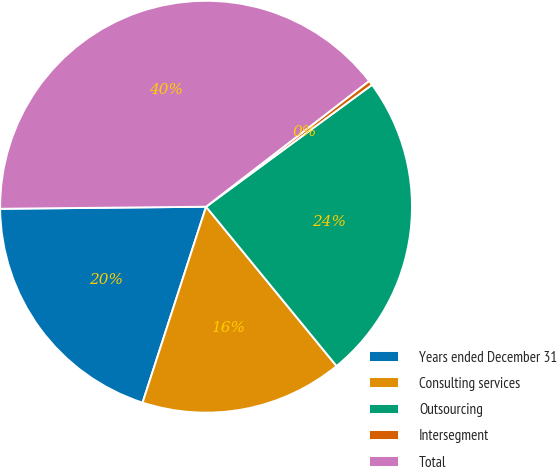<chart> <loc_0><loc_0><loc_500><loc_500><pie_chart><fcel>Years ended December 31<fcel>Consulting services<fcel>Outsourcing<fcel>Intersegment<fcel>Total<nl><fcel>19.85%<fcel>15.91%<fcel>24.16%<fcel>0.37%<fcel>39.7%<nl></chart> 